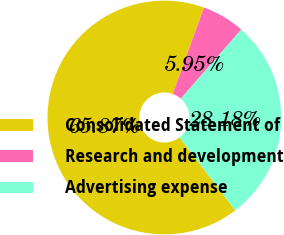Convert chart. <chart><loc_0><loc_0><loc_500><loc_500><pie_chart><fcel>Consolidated Statement of<fcel>Research and development<fcel>Advertising expense<nl><fcel>65.87%<fcel>5.95%<fcel>28.18%<nl></chart> 